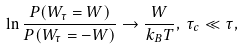Convert formula to latex. <formula><loc_0><loc_0><loc_500><loc_500>\ln \frac { P ( W _ { \tau } = W ) } { P ( W _ { \tau } = - W ) } \rightarrow \frac { W } { k _ { B } T } , \, \tau _ { c } \ll \tau ,</formula> 